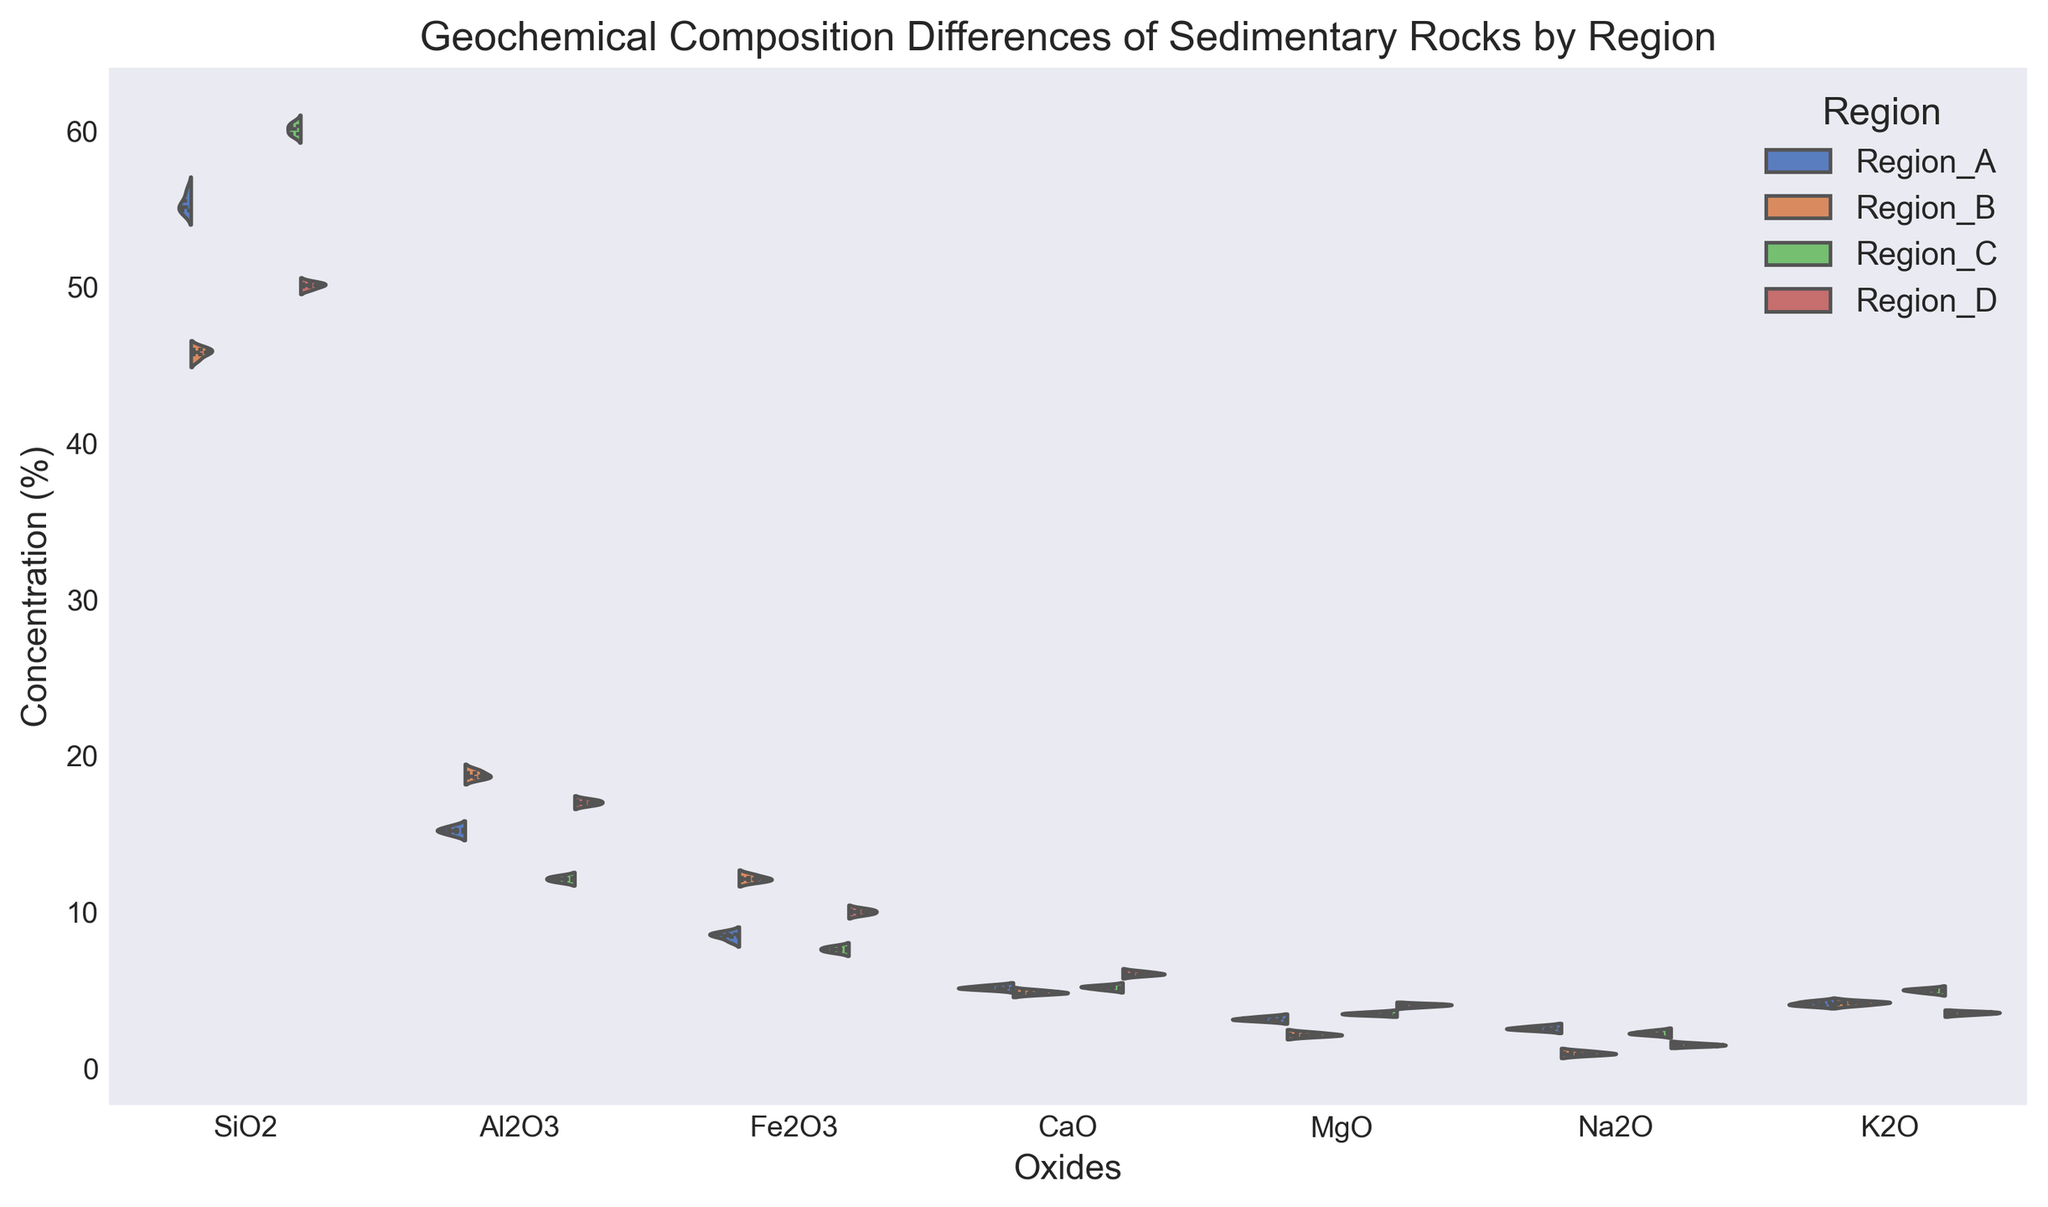Which region has the highest median concentration of SiO2? To determine which region has the highest median concentration of SiO2, compare the median line within each violin illustrated for SiO2 concentrations.
Answer: Region_C Which oxides show the greatest concentration variance for Region_B? To identify which oxides display the largest concentration variance for Region_B, observe the width and spread of the violins corresponding to Region_B for each oxide. The more spread out and wider the violin, the greater the variance.
Answer: Fe2O3 What is the typical range of the interquartile range (IQR) for Al2O3 in Region_D? The IQR is represented by the central part of the violin plot, typically indicated by a thicker line or a box, depending on the plot styling. Look for these indications for Al2O3 of Region_D to estimate the IQR range.
Answer: Approximately 16.8 - 17.2 How does the concentration of MgO in Region_A compare to Region_D? Observe the position of the medians and the spread of the distribution for MgO concentrations in both regions. Compare their central tendency and spread to determine their relationship.
Answer: Region_A < Region_D What visual characteristic indicates the greatest median value for K2O? The median of a violin plot is usually indicated by a thick line or point within the split of the violin. Look for the highest position of this line for K2O.
Answer: Region_C Which region has the most consistent (least variable) concentration of CaO? Consistency in concentration means less variation, so look for the narrowest and least spread out violin plot for CaO concentrations across regions.
Answer: Region_C Are there any oxides where the median concentrations are roughly equal across all regions? Check for oxides with almost the same median line within the violins across all regions, indicating similar median concentrations.
Answer: K2O For which oxide do Region_A and Region_B show the most significant difference in distribution shape? Compare the shape and spread of the violins for all oxides between Region_A and Region_B. Identify the oxide with the starkest contrast in their distribution shapes.
Answer: Fe2O3 What is the range of Fe2O3 concentration in Region_C? Observe the full spread of the violin plot representing Fe2O3 in Region_C to identify the minimum and maximum concentration values.
Answer: Approximately 7.4 - 7.8 Which region has the lowest median concentration for Na2O? Compare the median lines within the Na2O violins for all regions to find the lowest positioned median.
Answer: Region_B 